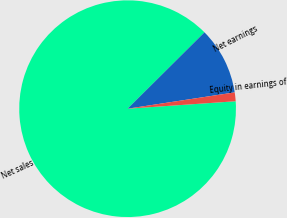Convert chart to OTSL. <chart><loc_0><loc_0><loc_500><loc_500><pie_chart><fcel>Net sales<fcel>Net earnings<fcel>Equity in earnings of<nl><fcel>88.65%<fcel>10.04%<fcel>1.31%<nl></chart> 